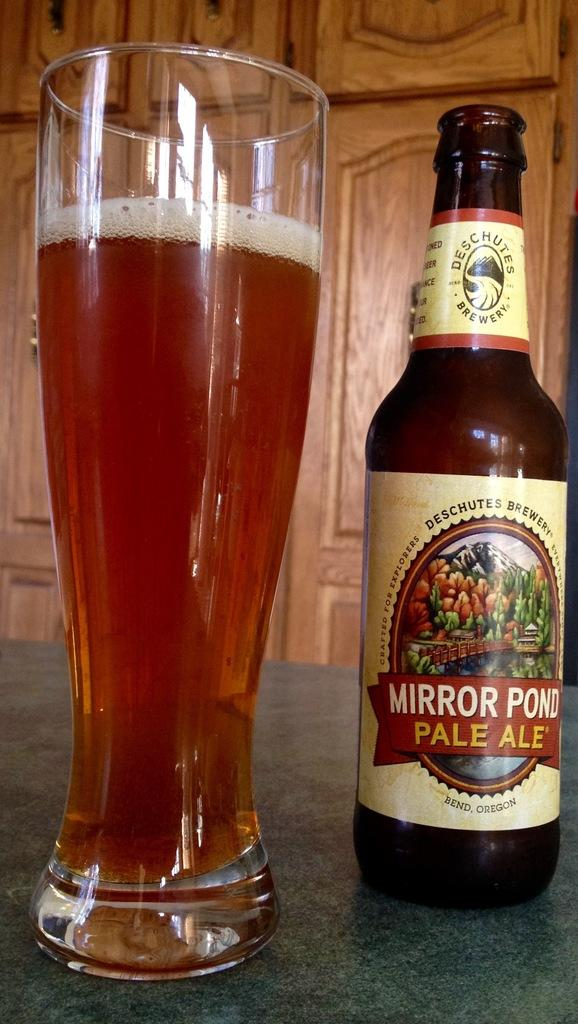<image>
Offer a succinct explanation of the picture presented. An open bottle of Mirror Pond next to a full pint of beer sitting on a table. 